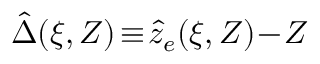Convert formula to latex. <formula><loc_0><loc_0><loc_500><loc_500>\hat { \Delta } ( \xi , Z ) \, \equiv \, \hat { z } _ { e } ( \xi , Z ) \, - \, Z</formula> 